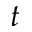<formula> <loc_0><loc_0><loc_500><loc_500>t</formula> 